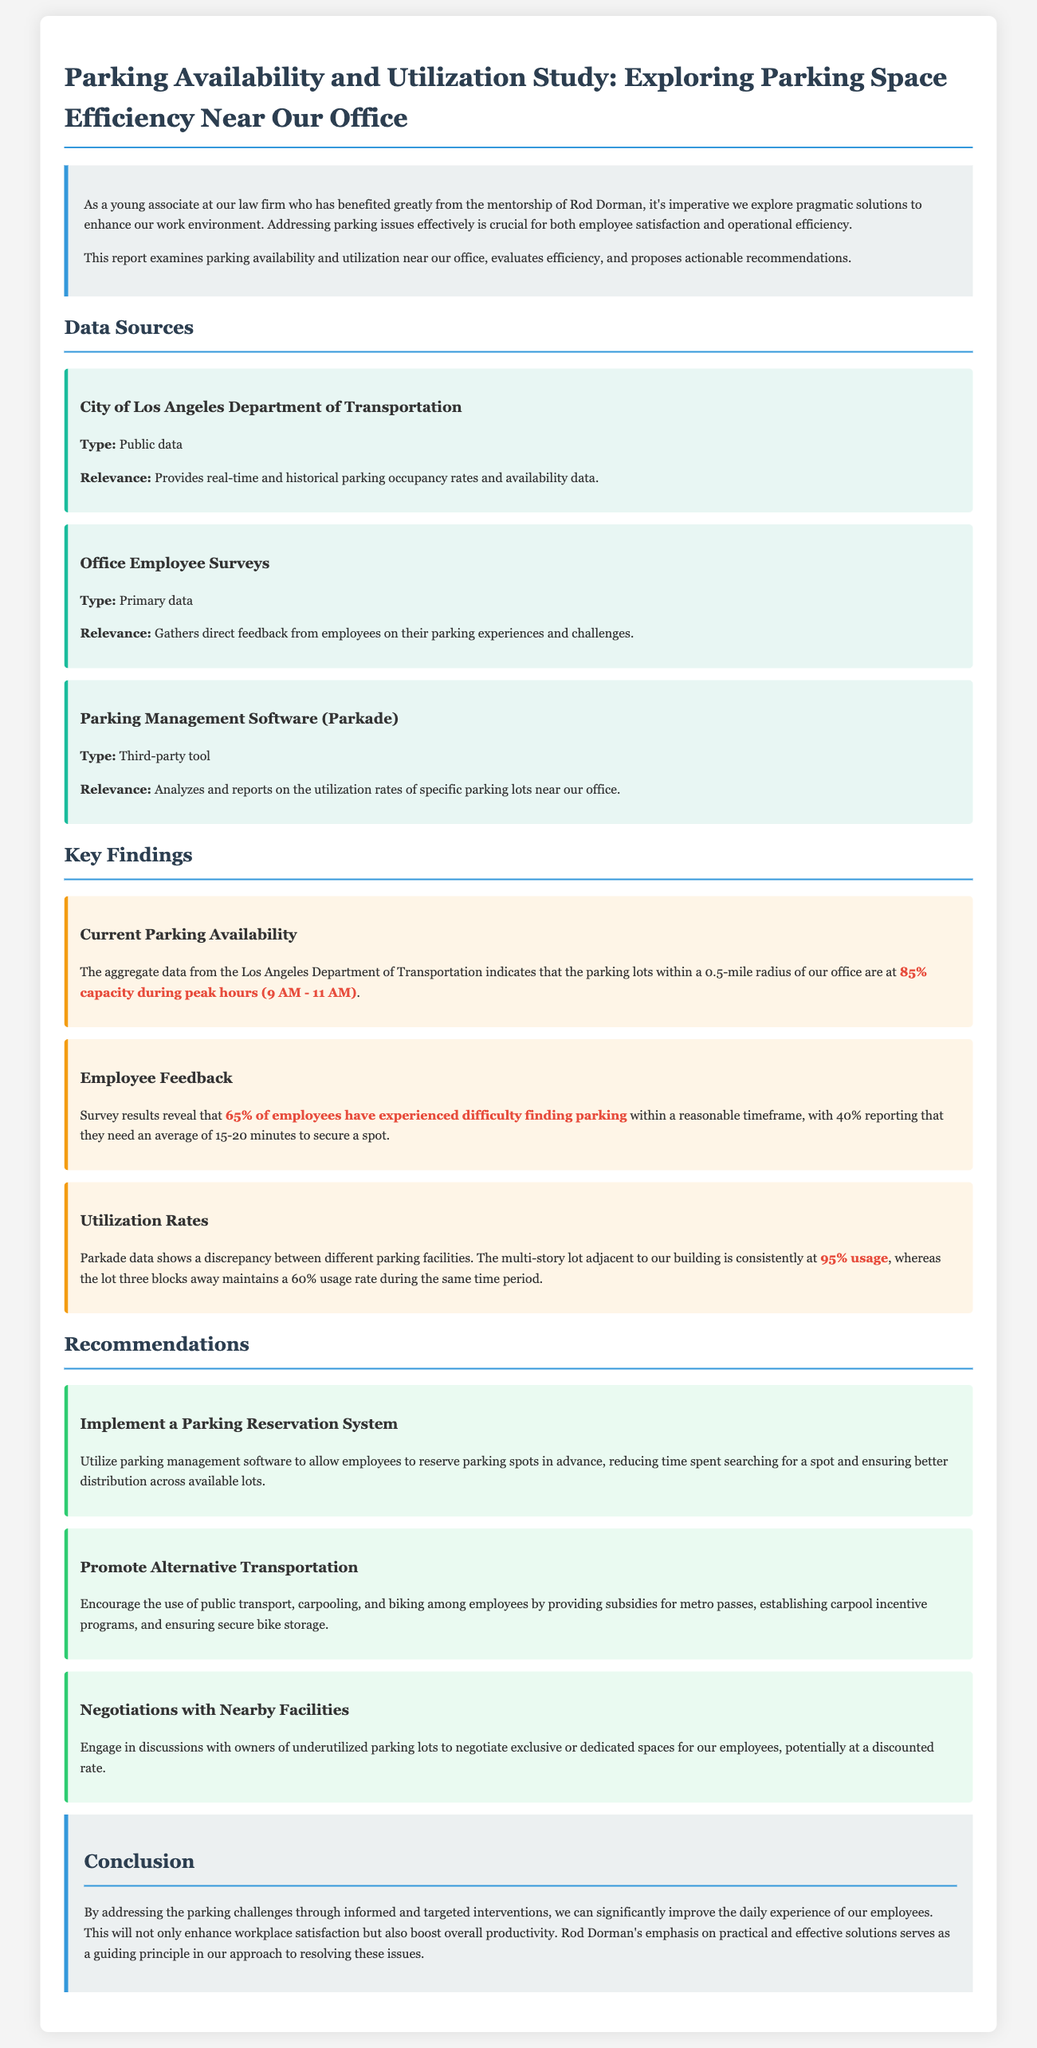What is the parking capacity during peak hours? The aggregate data indicates that parking lots are at 85% capacity during peak hours (9 AM - 11 AM).
Answer: 85% What percentage of employees struggled to find parking? Survey results show that 65% of employees have experienced difficulty finding parking.
Answer: 65% How long do 40% of employees typically take to secure a parking spot? The report states that 40% of employees need an average of 15-20 minutes to find a parking spot.
Answer: 15-20 minutes What is the utilization rate of the multi-story lot adjacent to the building? Parkade data reveals that the multi-story lot adjacent to the building is at 95% usage.
Answer: 95% What type of data is provided by the City of Los Angeles Department of Transportation? This source provides real-time and historical parking occupancy rates and availability data.
Answer: Real-time and historical data What is one recommendation regarding alternative transportation? One recommendation is to encourage the use of public transport among employees.
Answer: Encourage public transport What might the firm negotiate with the owners of underutilized parking lots? The firm could negotiate exclusive or dedicated spaces for employees at potentially discounted rates.
Answer: Exclusive or dedicated spaces What guiding principle is emphasized by Rod Dorman? Rod Dorman's emphasis on practical and effective solutions serves as a guiding principle.
Answer: Practical and effective solutions 